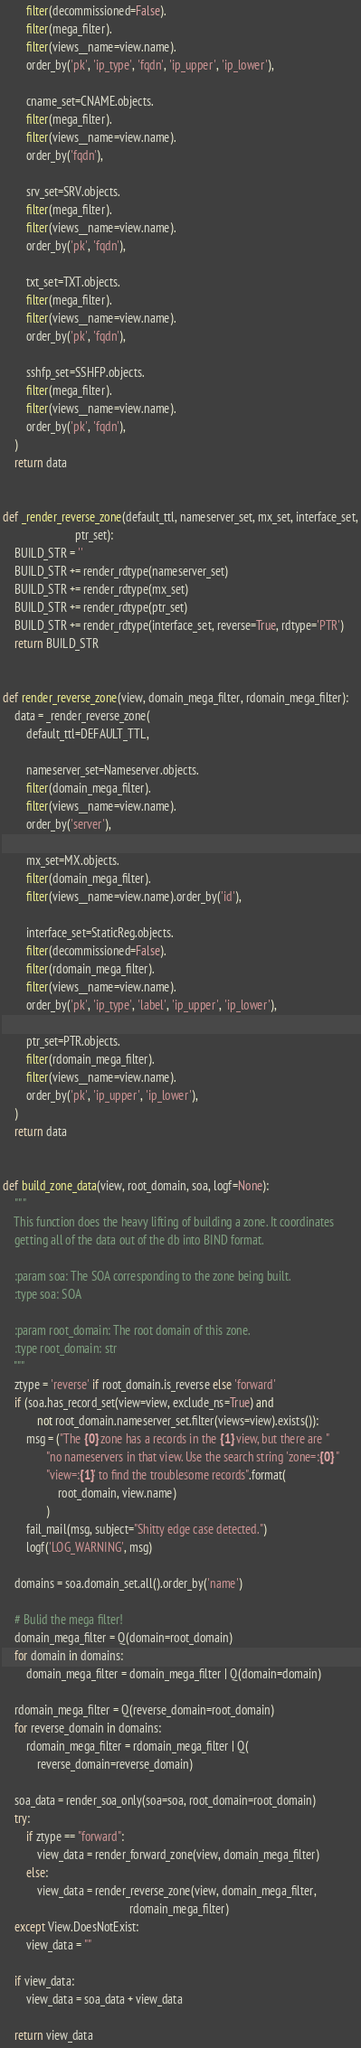<code> <loc_0><loc_0><loc_500><loc_500><_Python_>        filter(decommissioned=False).
        filter(mega_filter).
        filter(views__name=view.name).
        order_by('pk', 'ip_type', 'fqdn', 'ip_upper', 'ip_lower'),

        cname_set=CNAME.objects.
        filter(mega_filter).
        filter(views__name=view.name).
        order_by('fqdn'),

        srv_set=SRV.objects.
        filter(mega_filter).
        filter(views__name=view.name).
        order_by('pk', 'fqdn'),

        txt_set=TXT.objects.
        filter(mega_filter).
        filter(views__name=view.name).
        order_by('pk', 'fqdn'),

        sshfp_set=SSHFP.objects.
        filter(mega_filter).
        filter(views__name=view.name).
        order_by('pk', 'fqdn'),
    )
    return data


def _render_reverse_zone(default_ttl, nameserver_set, mx_set, interface_set,
                         ptr_set):
    BUILD_STR = ''
    BUILD_STR += render_rdtype(nameserver_set)
    BUILD_STR += render_rdtype(mx_set)
    BUILD_STR += render_rdtype(ptr_set)
    BUILD_STR += render_rdtype(interface_set, reverse=True, rdtype='PTR')
    return BUILD_STR


def render_reverse_zone(view, domain_mega_filter, rdomain_mega_filter):
    data = _render_reverse_zone(
        default_ttl=DEFAULT_TTL,

        nameserver_set=Nameserver.objects.
        filter(domain_mega_filter).
        filter(views__name=view.name).
        order_by('server'),

        mx_set=MX.objects.
        filter(domain_mega_filter).
        filter(views__name=view.name).order_by('id'),

        interface_set=StaticReg.objects.
        filter(decommissioned=False).
        filter(rdomain_mega_filter).
        filter(views__name=view.name).
        order_by('pk', 'ip_type', 'label', 'ip_upper', 'ip_lower'),

        ptr_set=PTR.objects.
        filter(rdomain_mega_filter).
        filter(views__name=view.name).
        order_by('pk', 'ip_upper', 'ip_lower'),
    )
    return data


def build_zone_data(view, root_domain, soa, logf=None):
    """
    This function does the heavy lifting of building a zone. It coordinates
    getting all of the data out of the db into BIND format.

    :param soa: The SOA corresponding to the zone being built.
    :type soa: SOA

    :param root_domain: The root domain of this zone.
    :type root_domain: str
    """
    ztype = 'reverse' if root_domain.is_reverse else 'forward'
    if (soa.has_record_set(view=view, exclude_ns=True) and
            not root_domain.nameserver_set.filter(views=view).exists()):
        msg = ("The {0} zone has a records in the {1} view, but there are "
               "no nameservers in that view. Use the search string 'zone=:{0} "
               "view=:{1}' to find the troublesome records".format(
                   root_domain, view.name)
               )
        fail_mail(msg, subject="Shitty edge case detected.")
        logf('LOG_WARNING', msg)

    domains = soa.domain_set.all().order_by('name')

    # Bulid the mega filter!
    domain_mega_filter = Q(domain=root_domain)
    for domain in domains:
        domain_mega_filter = domain_mega_filter | Q(domain=domain)

    rdomain_mega_filter = Q(reverse_domain=root_domain)
    for reverse_domain in domains:
        rdomain_mega_filter = rdomain_mega_filter | Q(
            reverse_domain=reverse_domain)

    soa_data = render_soa_only(soa=soa, root_domain=root_domain)
    try:
        if ztype == "forward":
            view_data = render_forward_zone(view, domain_mega_filter)
        else:
            view_data = render_reverse_zone(view, domain_mega_filter,
                                            rdomain_mega_filter)
    except View.DoesNotExist:
        view_data = ""

    if view_data:
        view_data = soa_data + view_data

    return view_data
</code> 